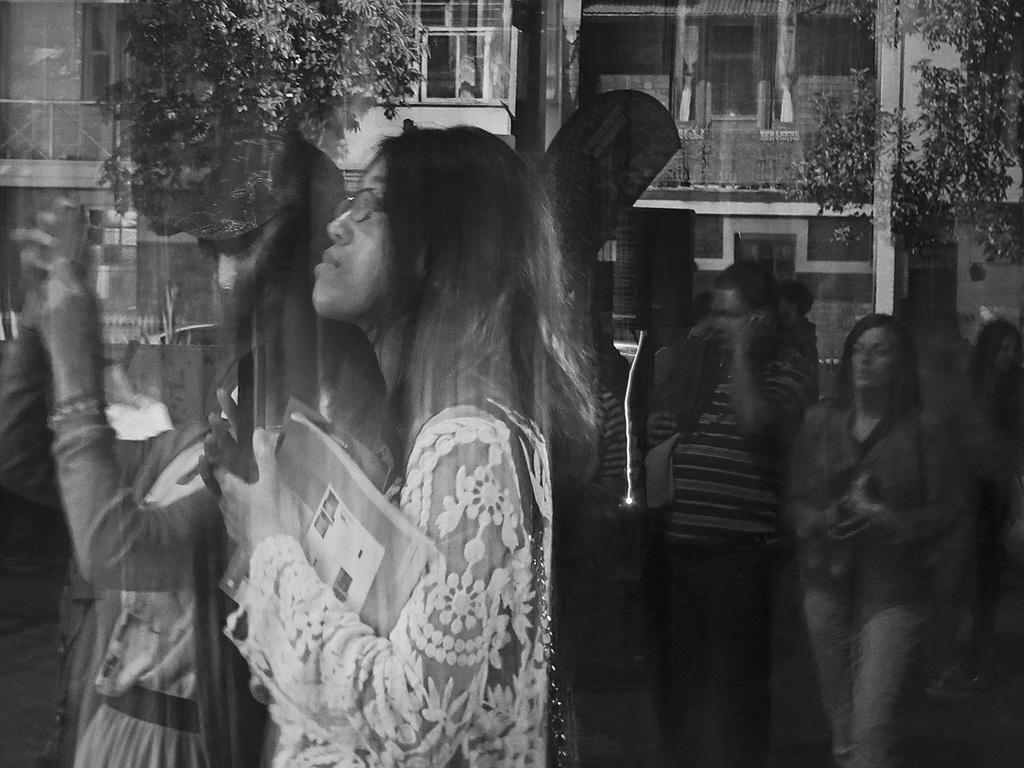How would you summarize this image in a sentence or two? In this image I can see few people are standing and I can see she is holding a book. In the background I can see few trees, building and I can see this image is little bit blurry. I can also see this image is black and white in colour. 